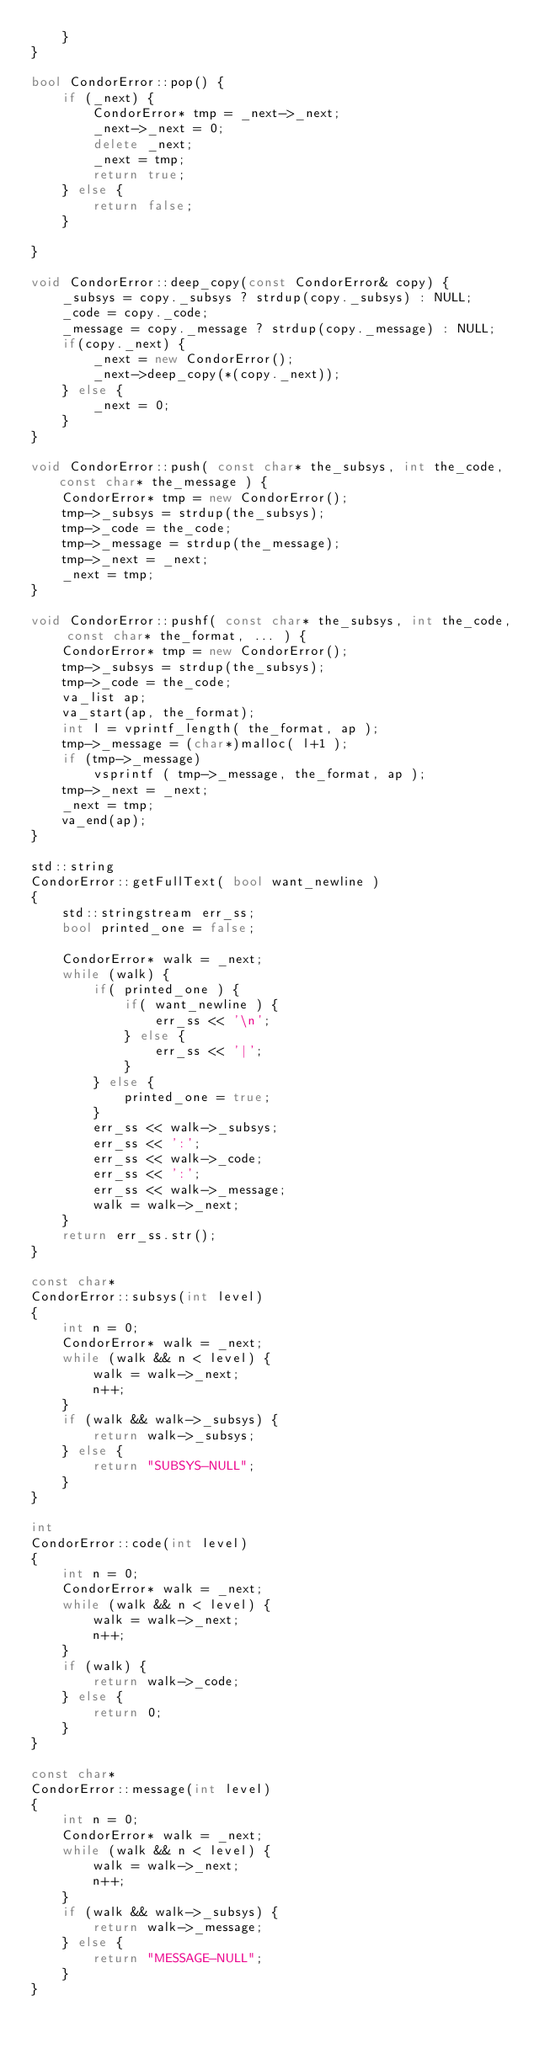Convert code to text. <code><loc_0><loc_0><loc_500><loc_500><_C++_>	}
}

bool CondorError::pop() {
	if (_next) {
		CondorError* tmp = _next->_next;
		_next->_next = 0;
		delete _next;
		_next = tmp;
		return true;
	} else {
		return false;
	}

}

void CondorError::deep_copy(const CondorError& copy) {
	_subsys = copy._subsys ? strdup(copy._subsys) : NULL;
	_code = copy._code;
	_message = copy._message ? strdup(copy._message) : NULL;
	if(copy._next) {
		_next = new CondorError();
		_next->deep_copy(*(copy._next));
	} else {
		_next = 0;
	}
}

void CondorError::push( const char* the_subsys, int the_code, const char* the_message ) {
	CondorError* tmp = new CondorError();
	tmp->_subsys = strdup(the_subsys);
	tmp->_code = the_code;
	tmp->_message = strdup(the_message);
	tmp->_next = _next;
	_next = tmp;
}

void CondorError::pushf( const char* the_subsys, int the_code, const char* the_format, ... ) {
	CondorError* tmp = new CondorError();
	tmp->_subsys = strdup(the_subsys);
	tmp->_code = the_code;
	va_list ap;
	va_start(ap, the_format);
	int l = vprintf_length( the_format, ap );
	tmp->_message = (char*)malloc( l+1 );
	if (tmp->_message)
		vsprintf ( tmp->_message, the_format, ap );
	tmp->_next = _next;
	_next = tmp;
	va_end(ap);
}

std::string
CondorError::getFullText( bool want_newline )
{
	std::stringstream err_ss;
	bool printed_one = false;

	CondorError* walk = _next;
	while (walk) {
		if( printed_one ) {
			if( want_newline ) {
				err_ss << '\n';
			} else {
				err_ss << '|';
			}
		} else {
			printed_one = true;
		}
		err_ss << walk->_subsys;
		err_ss << ':';
		err_ss << walk->_code;
		err_ss << ':';
		err_ss << walk->_message;
		walk = walk->_next;
	}
	return err_ss.str();
}

const char*
CondorError::subsys(int level)
{
	int n = 0;
	CondorError* walk = _next;
	while (walk && n < level) {
		walk = walk->_next;
		n++;
	}
	if (walk && walk->_subsys) {
		return walk->_subsys;
	} else {
		return "SUBSYS-NULL";
	}
}

int
CondorError::code(int level)
{
	int n = 0;
	CondorError* walk = _next;
	while (walk && n < level) {
		walk = walk->_next;
		n++;
	}
	if (walk) {
		return walk->_code;
	} else {
		return 0;
	}
}

const char*
CondorError::message(int level)
{
	int n = 0;
	CondorError* walk = _next;
	while (walk && n < level) {
		walk = walk->_next;
		n++;
	}
	if (walk && walk->_subsys) {
		return walk->_message;
	} else {
		return "MESSAGE-NULL";
	}
}

</code> 